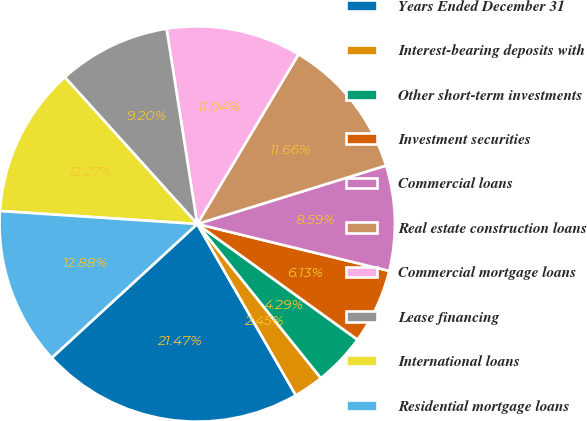<chart> <loc_0><loc_0><loc_500><loc_500><pie_chart><fcel>Years Ended December 31<fcel>Interest-bearing deposits with<fcel>Other short-term investments<fcel>Investment securities<fcel>Commercial loans<fcel>Real estate construction loans<fcel>Commercial mortgage loans<fcel>Lease financing<fcel>International loans<fcel>Residential mortgage loans<nl><fcel>21.47%<fcel>2.45%<fcel>4.29%<fcel>6.13%<fcel>8.59%<fcel>11.66%<fcel>11.04%<fcel>9.2%<fcel>12.27%<fcel>12.88%<nl></chart> 